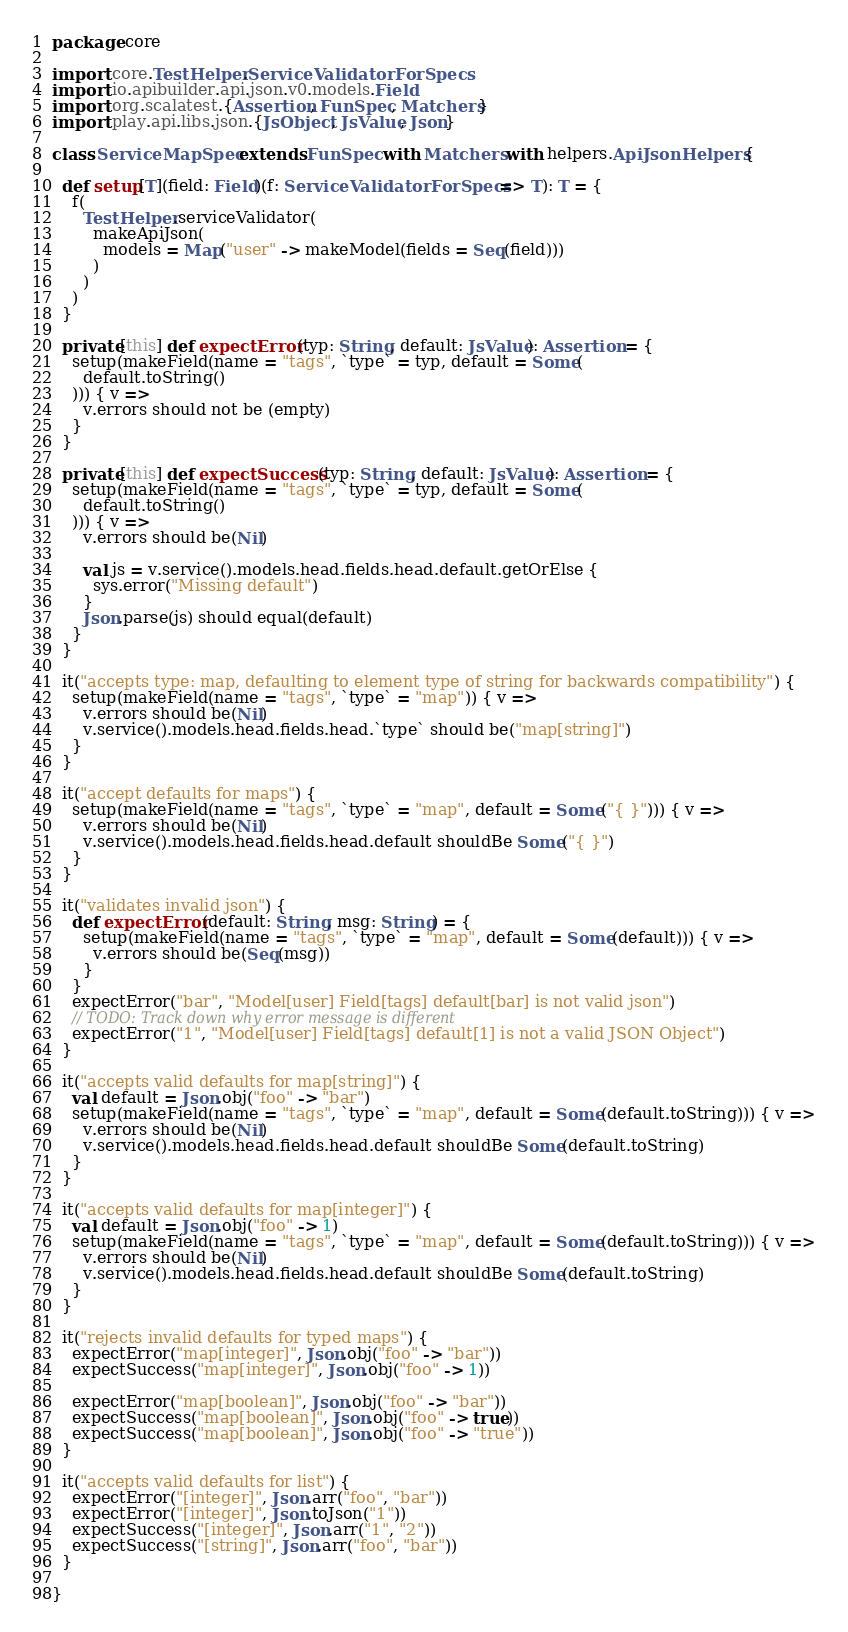<code> <loc_0><loc_0><loc_500><loc_500><_Scala_>package core

import core.TestHelper.ServiceValidatorForSpecs
import io.apibuilder.api.json.v0.models.Field
import org.scalatest.{Assertion, FunSpec, Matchers}
import play.api.libs.json.{JsObject, JsValue, Json}

class ServiceMapSpec extends FunSpec with Matchers with helpers.ApiJsonHelpers {

  def setup[T](field: Field)(f: ServiceValidatorForSpecs => T): T = {
    f(
      TestHelper.serviceValidator(
        makeApiJson(
          models = Map("user" -> makeModel(fields = Seq(field)))
        )
      )
    )
  }

  private[this] def expectError(typ: String, default: JsValue): Assertion = {
    setup(makeField(name = "tags", `type` = typ, default = Some(
      default.toString()
    ))) { v =>
      v.errors should not be (empty)
    }
  }

  private[this] def expectSuccess(typ: String, default: JsValue): Assertion = {
    setup(makeField(name = "tags", `type` = typ, default = Some(
      default.toString()
    ))) { v =>
      v.errors should be(Nil)

      val js = v.service().models.head.fields.head.default.getOrElse {
        sys.error("Missing default")
      }
      Json.parse(js) should equal(default)
    }
  }

  it("accepts type: map, defaulting to element type of string for backwards compatibility") {
    setup(makeField(name = "tags", `type` = "map")) { v =>
      v.errors should be(Nil)
      v.service().models.head.fields.head.`type` should be("map[string]")
    }
  }

  it("accept defaults for maps") {
    setup(makeField(name = "tags", `type` = "map", default = Some("{ }"))) { v =>
      v.errors should be(Nil)
      v.service().models.head.fields.head.default shouldBe Some("{ }")
    }
  }

  it("validates invalid json") {
    def expectError(default: String, msg: String) = {
      setup(makeField(name = "tags", `type` = "map", default = Some(default))) { v =>
        v.errors should be(Seq(msg))
      }
    }
    expectError("bar", "Model[user] Field[tags] default[bar] is not valid json")
    // TODO: Track down why error message is different
    expectError("1", "Model[user] Field[tags] default[1] is not a valid JSON Object")
  }

  it("accepts valid defaults for map[string]") {
    val default = Json.obj("foo" -> "bar")
    setup(makeField(name = "tags", `type` = "map", default = Some(default.toString))) { v =>
      v.errors should be(Nil)
      v.service().models.head.fields.head.default shouldBe Some(default.toString)
    }
  }

  it("accepts valid defaults for map[integer]") {
    val default = Json.obj("foo" -> 1)
    setup(makeField(name = "tags", `type` = "map", default = Some(default.toString))) { v =>
      v.errors should be(Nil)
      v.service().models.head.fields.head.default shouldBe Some(default.toString)
    }
  }

  it("rejects invalid defaults for typed maps") {
    expectError("map[integer]", Json.obj("foo" -> "bar"))
    expectSuccess("map[integer]", Json.obj("foo" -> 1))

    expectError("map[boolean]", Json.obj("foo" -> "bar"))
    expectSuccess("map[boolean]", Json.obj("foo" -> true))
    expectSuccess("map[boolean]", Json.obj("foo" -> "true"))
  }

  it("accepts valid defaults for list") {
    expectError("[integer]", Json.arr("foo", "bar"))
    expectError("[integer]", Json.toJson("1"))
    expectSuccess("[integer]", Json.arr("1", "2"))
    expectSuccess("[string]", Json.arr("foo", "bar"))
  }

}
</code> 